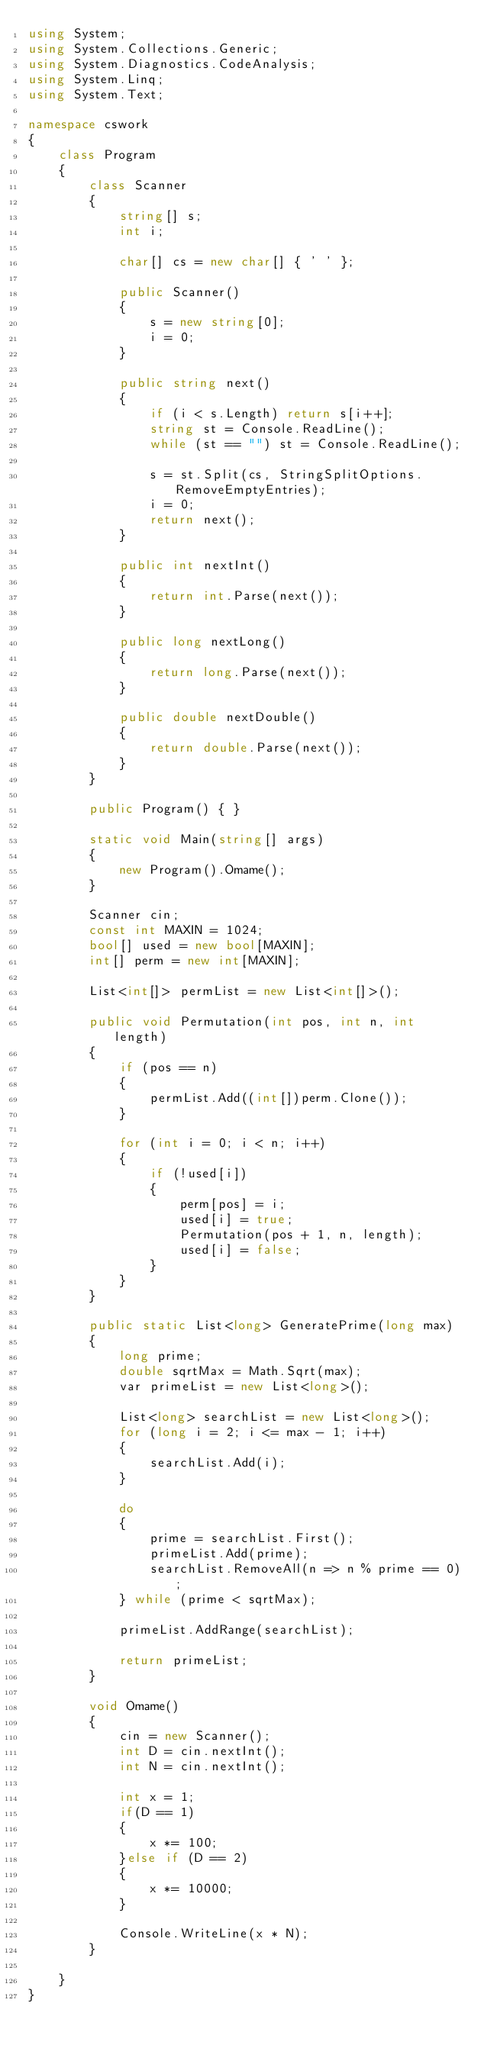<code> <loc_0><loc_0><loc_500><loc_500><_C#_>using System;
using System.Collections.Generic;
using System.Diagnostics.CodeAnalysis;
using System.Linq;
using System.Text;

namespace cswork
{
    class Program
    {
        class Scanner
        {
            string[] s;
            int i;

            char[] cs = new char[] { ' ' };

            public Scanner()
            {
                s = new string[0];
                i = 0;
            }

            public string next()
            {
                if (i < s.Length) return s[i++];
                string st = Console.ReadLine();
                while (st == "") st = Console.ReadLine();

                s = st.Split(cs, StringSplitOptions.RemoveEmptyEntries);
                i = 0;
                return next();
            }

            public int nextInt()
            {
                return int.Parse(next());
            }

            public long nextLong()
            {
                return long.Parse(next());
            }

            public double nextDouble()
            {
                return double.Parse(next());
            }
        }

        public Program() { }

        static void Main(string[] args)
        {
            new Program().Omame();
        }

        Scanner cin;
        const int MAXIN = 1024;
        bool[] used = new bool[MAXIN];
        int[] perm = new int[MAXIN];

        List<int[]> permList = new List<int[]>();

        public void Permutation(int pos, int n, int length)
        {
            if (pos == n)
            {
                permList.Add((int[])perm.Clone());
            }

            for (int i = 0; i < n; i++)
            {
                if (!used[i])
                {
                    perm[pos] = i;
                    used[i] = true;
                    Permutation(pos + 1, n, length);
                    used[i] = false;
                }
            }
        }

        public static List<long> GeneratePrime(long max)
        {
            long prime;
            double sqrtMax = Math.Sqrt(max);
            var primeList = new List<long>();

            List<long> searchList = new List<long>();
            for (long i = 2; i <= max - 1; i++)
            {
                searchList.Add(i);
            }

            do
            {
                prime = searchList.First();
                primeList.Add(prime);
                searchList.RemoveAll(n => n % prime == 0);
            } while (prime < sqrtMax);

            primeList.AddRange(searchList);

            return primeList;
        }

        void Omame()
        {
            cin = new Scanner();
            int D = cin.nextInt();
            int N = cin.nextInt();

            int x = 1;
            if(D == 1)
            {
                x *= 100;
            }else if (D == 2)
            {
                x *= 10000;
            }

            Console.WriteLine(x * N);
        }

    }
}
</code> 